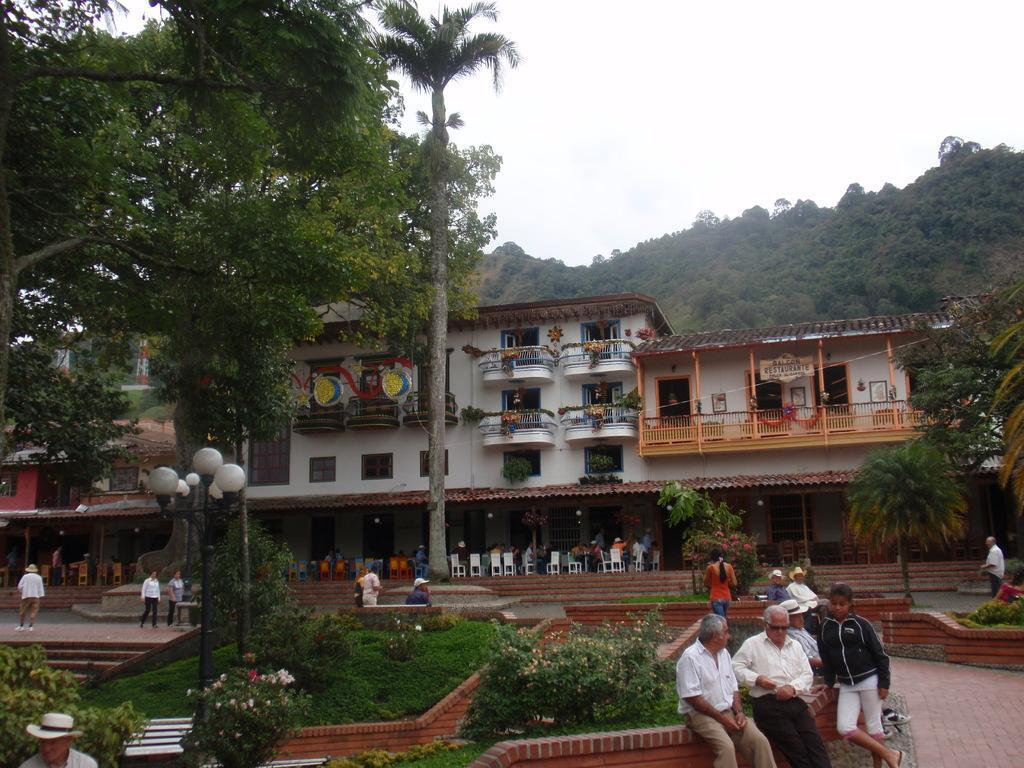Please provide a concise description of this image. In this image there is the sky truncated towards the top of the image, there are trees truncated towards the right of the image, there are trees truncated towards the left of the image, there are buildings, there is a tower, there is a building truncated towards the left of the image, there are chairs, there are persons sitting, there are persons walking, there is a pole, there are lights, there is grass, there are plants truncated towards the bottom of the image, there is a plant truncated towards the right of the image, there is board, there is text on the board, there are persons truncated towards the bottom of the image. 